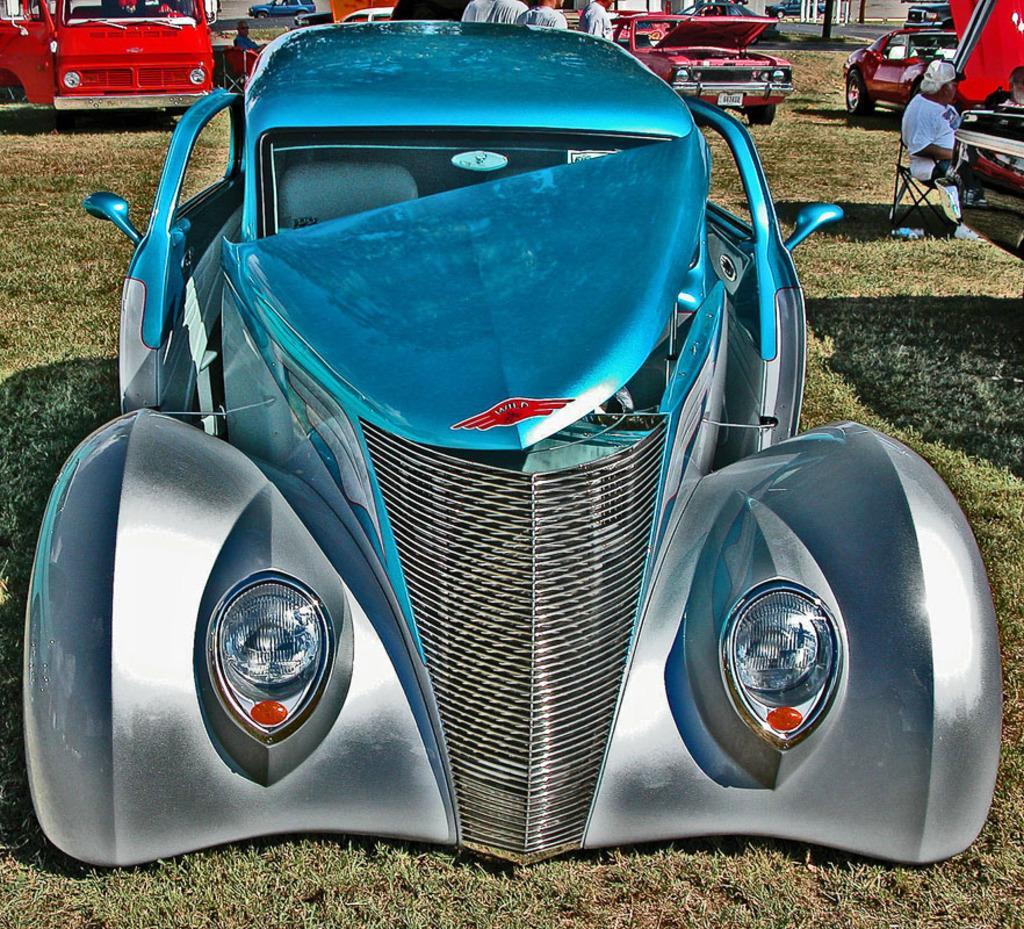How would you summarize this image in a sentence or two? In front of the picture, we see a blue color car. At the bottom, we see the grass. On the right side, we see a man is sitting on the chair. Beside him, we see the cars. Behind the car, we see the people are standing. Beside them, we see the cars parked on the grass. In the background, we see the blue color car is moving on the road and we even see the white poles. 